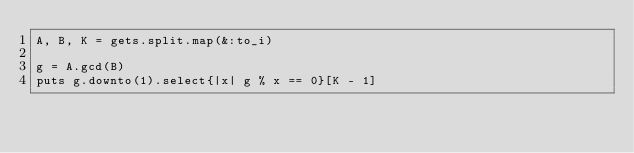Convert code to text. <code><loc_0><loc_0><loc_500><loc_500><_Ruby_>A, B, K = gets.split.map(&:to_i)

g = A.gcd(B)
puts g.downto(1).select{|x| g % x == 0}[K - 1]</code> 